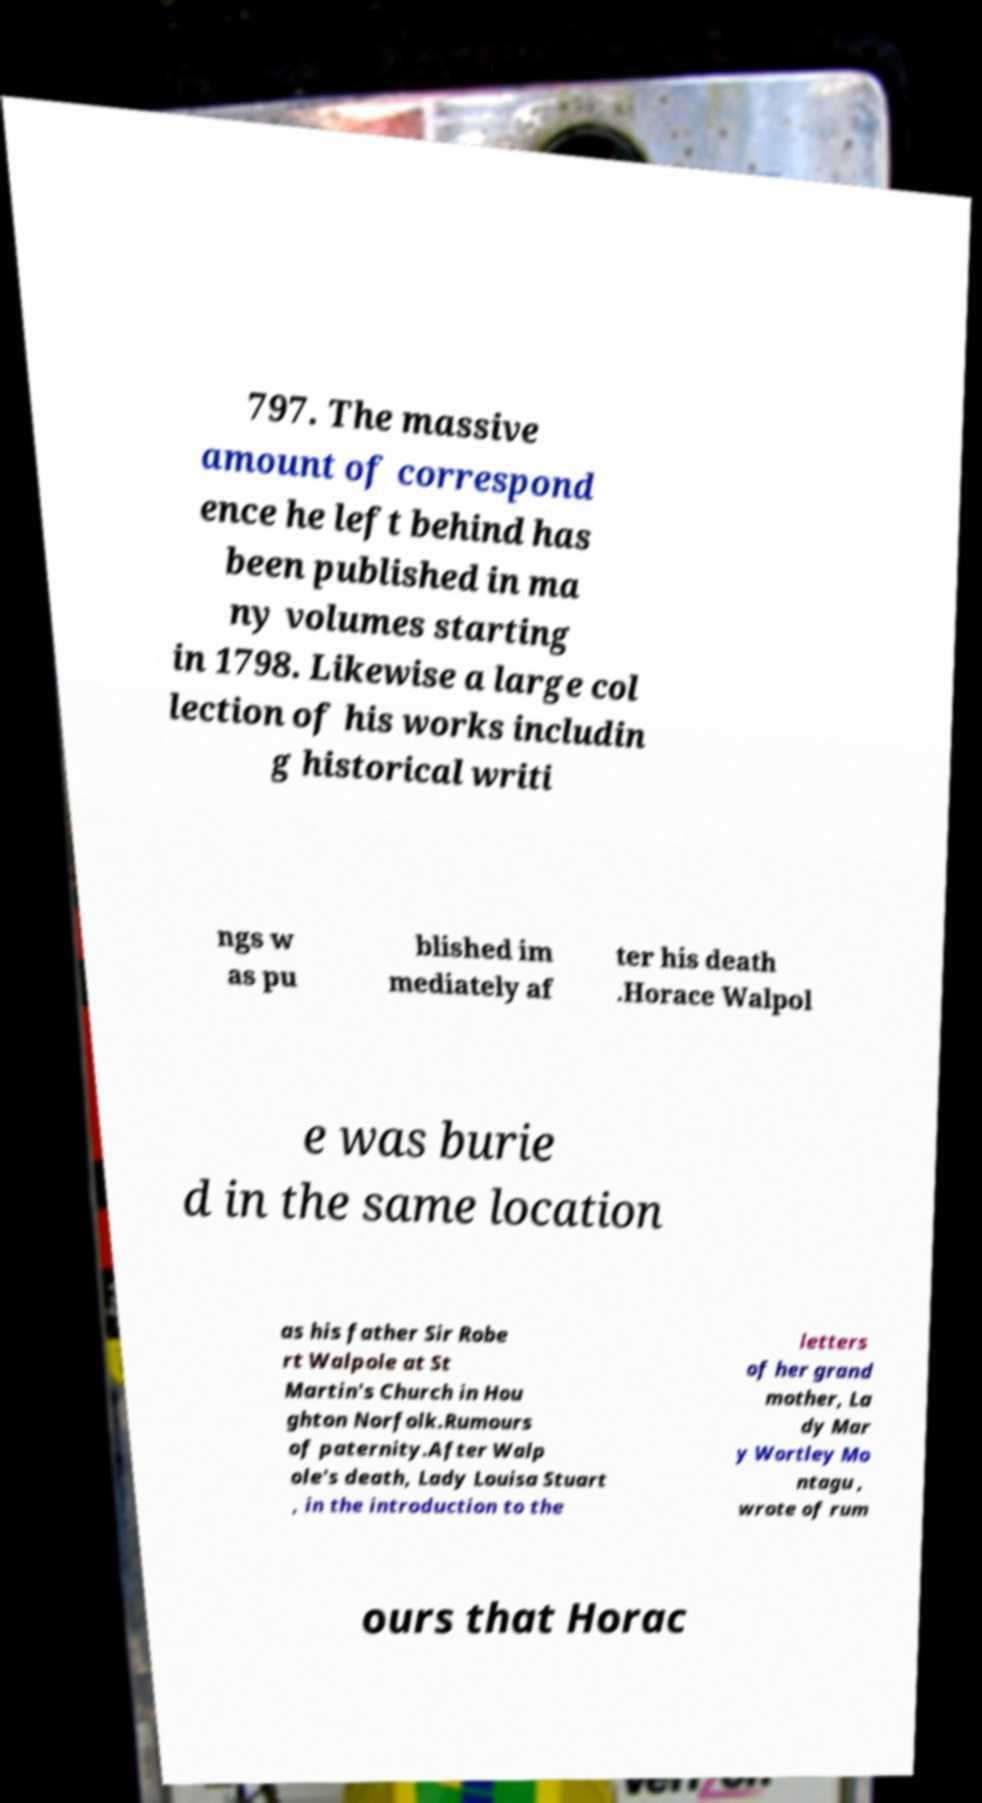Could you assist in decoding the text presented in this image and type it out clearly? 797. The massive amount of correspond ence he left behind has been published in ma ny volumes starting in 1798. Likewise a large col lection of his works includin g historical writi ngs w as pu blished im mediately af ter his death .Horace Walpol e was burie d in the same location as his father Sir Robe rt Walpole at St Martin's Church in Hou ghton Norfolk.Rumours of paternity.After Walp ole's death, Lady Louisa Stuart , in the introduction to the letters of her grand mother, La dy Mar y Wortley Mo ntagu , wrote of rum ours that Horac 